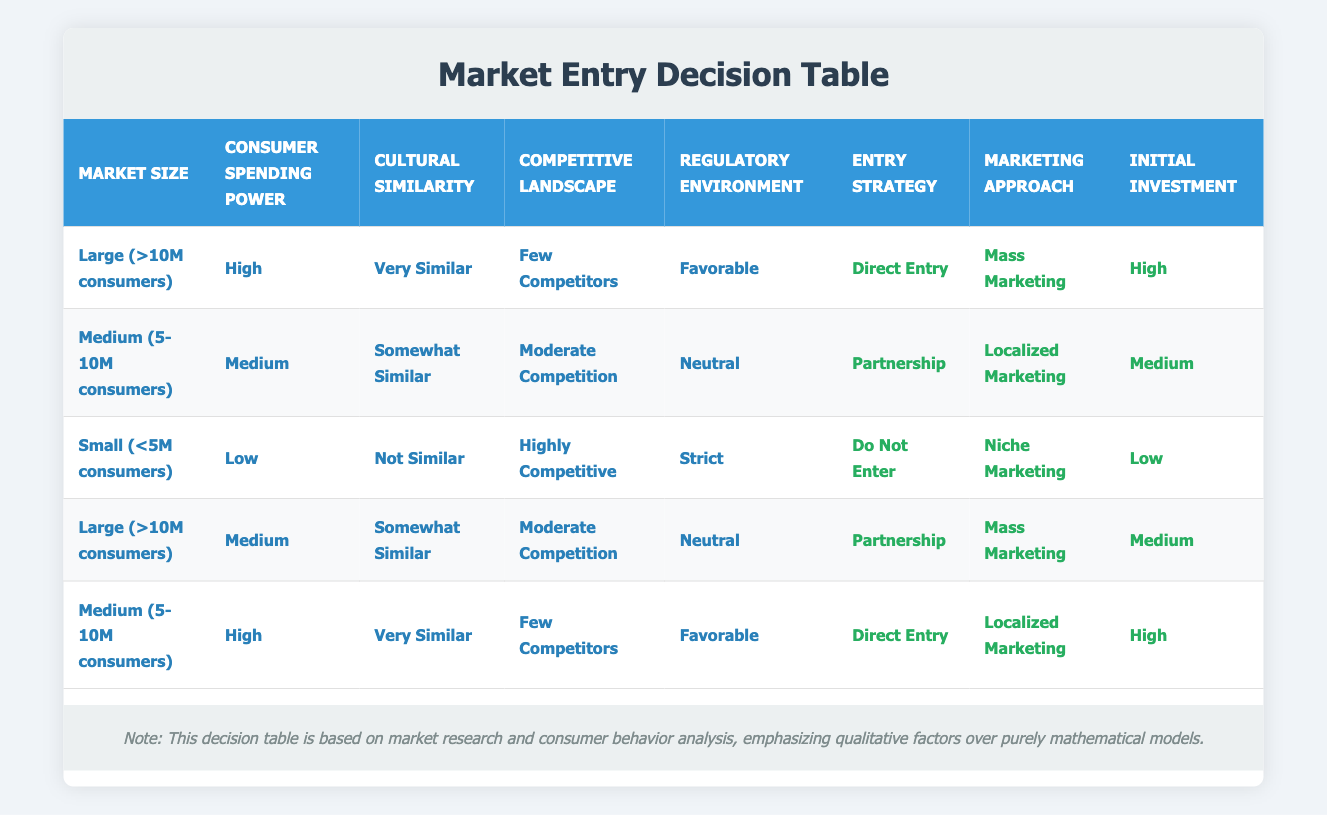What entry strategy is recommended for a market with a large size, high spending power, very similar culture, few competitors, and a favorable regulatory environment? According to the table, for a market with these specific conditions (Large size, High spending power, Very similar culture, Few competitors, and Favorable regulatory environment), the recommended entry strategy is "Direct Entry".
Answer: Direct Entry What marketing approach is recommended for a medium-sized market with medium consumer spending power and somewhat similar culture? The table indicates that for a Medium-sized market with Medium consumer spending power and Somewhat Similar culture, the recommended marketing approach is "Localized Marketing".
Answer: Localized Marketing Is a partnership recommended for markets that are both large and medium-sized with medium consumer spending power? The table shows that for a Large market with Medium consumer spending power, the recommended strategy is "Partnership", while for a Medium market with Medium spending power, it is also "Partnership". Therefore, the answer is yes, partnerships are recommended for both cases.
Answer: Yes What is the initial investment suggested in a highly competitive market with low consumer spending power? The table states that for a Small market with Low spending power and Highly Competitive landscape, the suggested initial investment is "Low".
Answer: Low What is the overall trend in entry strategies as market size decreases? By reviewing the table, we see that as market size decreases, the recommended entry strategies change from "Direct Entry" to "Partnership," and ultimately to "Do Not Enter" for small markets, indicating a trend where market size strongly influences the ability to enter the market successfully.
Answer: The trend reflects decreasing entry strategies with smaller markets What are the entry strategies for both large and medium-sized markets where consumer spending power is high? For a Large market with High spending power, the entry strategy is "Direct Entry". For a Medium market with High spending power, it again recommends "Direct Entry". Thus, both market sizes point towards "Direct Entry" for high spending power.
Answer: Direct Entry Is it advisable to enter a market with low consumer spending power and a highly competitive landscape? The table indicates that for a Small market with Low spending power and a Highly Competitive landscape, the suggestion is "Do Not Enter". Therefore, it is not advisable to enter such a market.
Answer: No For medium-sized markets with favorable regulatory environments, what marketing approach should be used? The table lists that for a Medium market with High spending power and Very Similar culture with a Favorable regulatory environment, the recommended marketing approach is "Localized Marketing". This indicates that localized strategies are effective in favorable conditions.
Answer: Localized Marketing What are the entry strategies for markets with a favorable regulatory environment? Analyzing the table, both a Large market with High spending power (Direct Entry) and a Medium market with High spending power (Direct Entry) suggest strong entry strategies, while in a Medium market with Medium spending power (Partnership), suggesting flexibility depending on market size as well.
Answer: Direct Entry and Partnership 